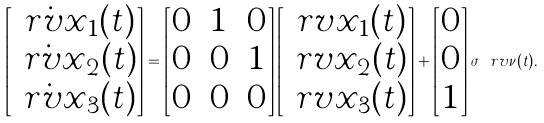<formula> <loc_0><loc_0><loc_500><loc_500>\begin{bmatrix} \dot { \ r v { x } } _ { 1 } ( t ) \\ \dot { \ r v { x } } _ { 2 } ( t ) \\ \dot { \ r v { x } } _ { 3 } ( t ) \end{bmatrix} = \begin{bmatrix} 0 & 1 & 0 \\ 0 & 0 & 1 \\ 0 & 0 & 0 \end{bmatrix} \begin{bmatrix} \ r v { x } _ { 1 } ( t ) \\ \ r v { x } _ { 2 } ( t ) \\ \ r v { x } _ { 3 } ( t ) \end{bmatrix} + \begin{bmatrix} 0 \\ 0 \\ 1 \end{bmatrix} \sigma \ r v { \nu } ( t ) .</formula> 